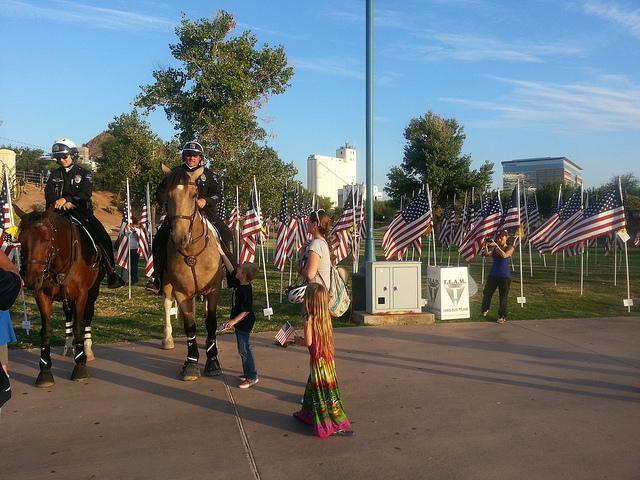How many people are there?
Give a very brief answer. 4. How many horses are in the picture?
Give a very brief answer. 2. How many trains can pass through this spot at once?
Give a very brief answer. 0. 